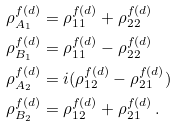Convert formula to latex. <formula><loc_0><loc_0><loc_500><loc_500>\rho _ { A _ { 1 } } ^ { f ( d ) } & = \rho _ { 1 1 } ^ { f ( d ) } + \rho _ { 2 2 } ^ { f ( d ) } \\ \rho _ { B _ { 1 } } ^ { f ( d ) } & = \rho _ { 1 1 } ^ { f ( d ) } - \rho _ { 2 2 } ^ { f ( d ) } \\ \rho _ { A _ { 2 } } ^ { f ( d ) } & = i ( \rho _ { 1 2 } ^ { f ( d ) } - \rho _ { 2 1 } ^ { f ( d ) } ) \\ \rho _ { B _ { 2 } } ^ { f ( d ) } & = \rho _ { 1 2 } ^ { f ( d ) } + \rho _ { 2 1 } ^ { f ( d ) } \, .</formula> 